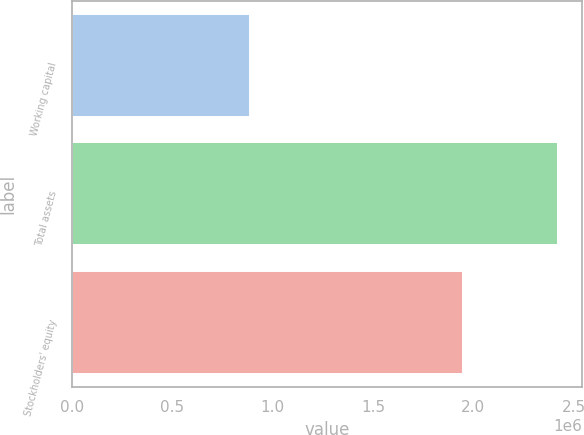Convert chart to OTSL. <chart><loc_0><loc_0><loc_500><loc_500><bar_chart><fcel>Working capital<fcel>Total assets<fcel>Stockholders' equity<nl><fcel>888551<fcel>2.42168e+06<fcel>1.95074e+06<nl></chart> 